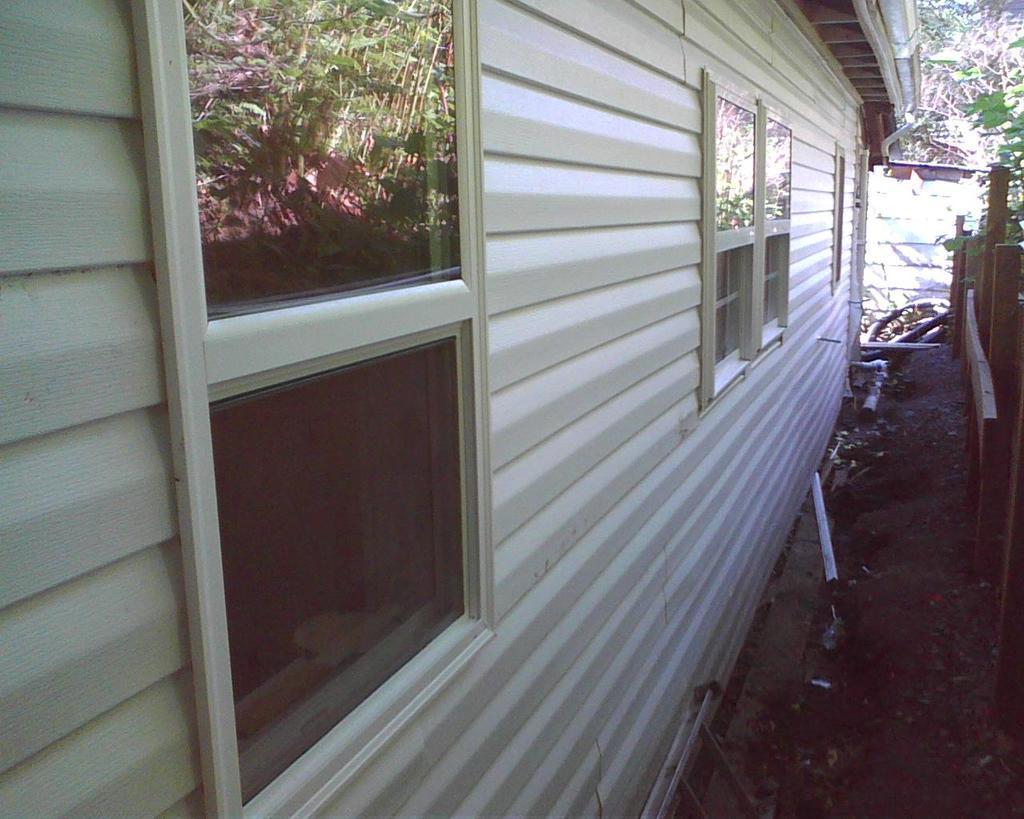In one or two sentences, can you explain what this image depicts? In this image we can see a building with windows. On the right side there is a wooden fencing. On the window there is reflection of plants. 